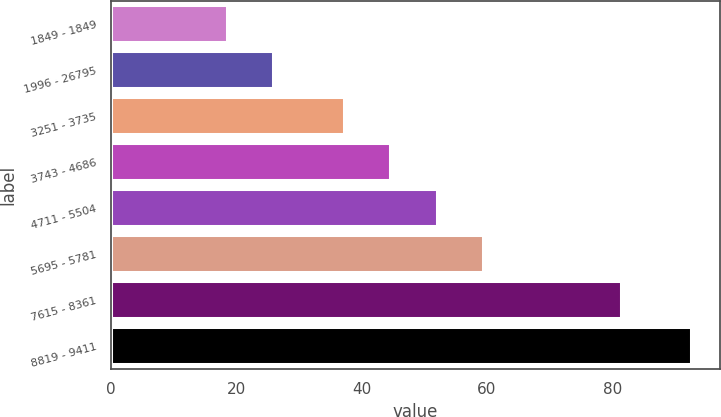Convert chart. <chart><loc_0><loc_0><loc_500><loc_500><bar_chart><fcel>1849 - 1849<fcel>1996 - 26795<fcel>3251 - 3735<fcel>3743 - 4686<fcel>4711 - 5504<fcel>5695 - 5781<fcel>7615 - 8361<fcel>8819 - 9411<nl><fcel>18.49<fcel>25.9<fcel>37.15<fcel>44.56<fcel>51.97<fcel>59.38<fcel>81.34<fcel>92.57<nl></chart> 